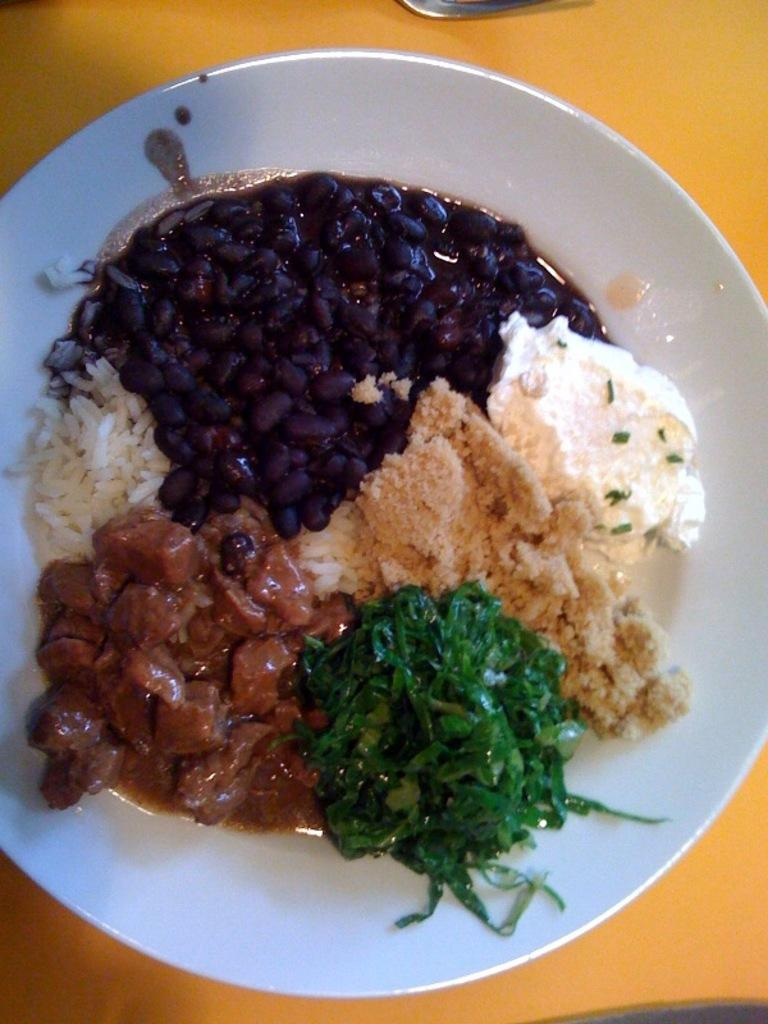What is present on the plate in the image? There is food on the plate in the image. What can be inferred about the location of the plate? The plate is on a yellow table. What type of street is visible in the image? There is no street visible in the image; it only shows a plate with food on a yellow table. 